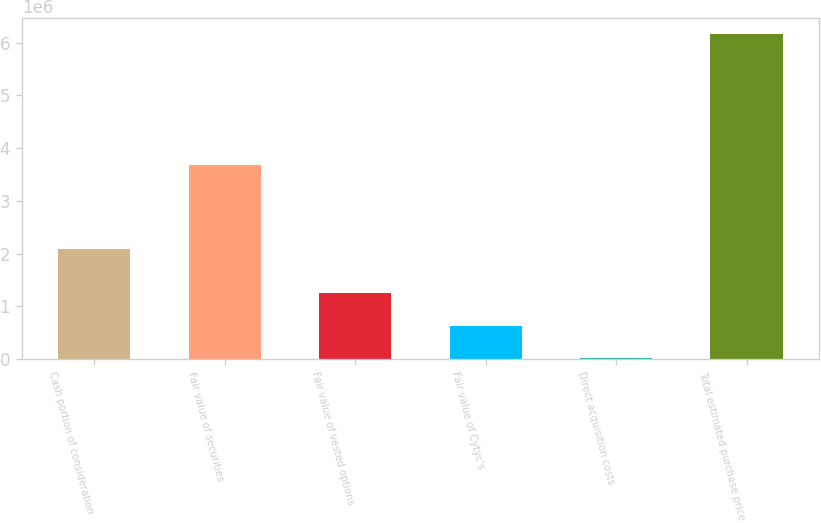Convert chart to OTSL. <chart><loc_0><loc_0><loc_500><loc_500><bar_chart><fcel>Cash portion of consideration<fcel>Fair value of securities<fcel>Fair value of vested options<fcel>Fair value of Cytyc's<fcel>Direct acquisition costs<fcel>Total estimated purchase price<nl><fcel>2.0948e+06<fcel>3.6715e+06<fcel>1.25074e+06<fcel>637470<fcel>24200<fcel>6.1569e+06<nl></chart> 